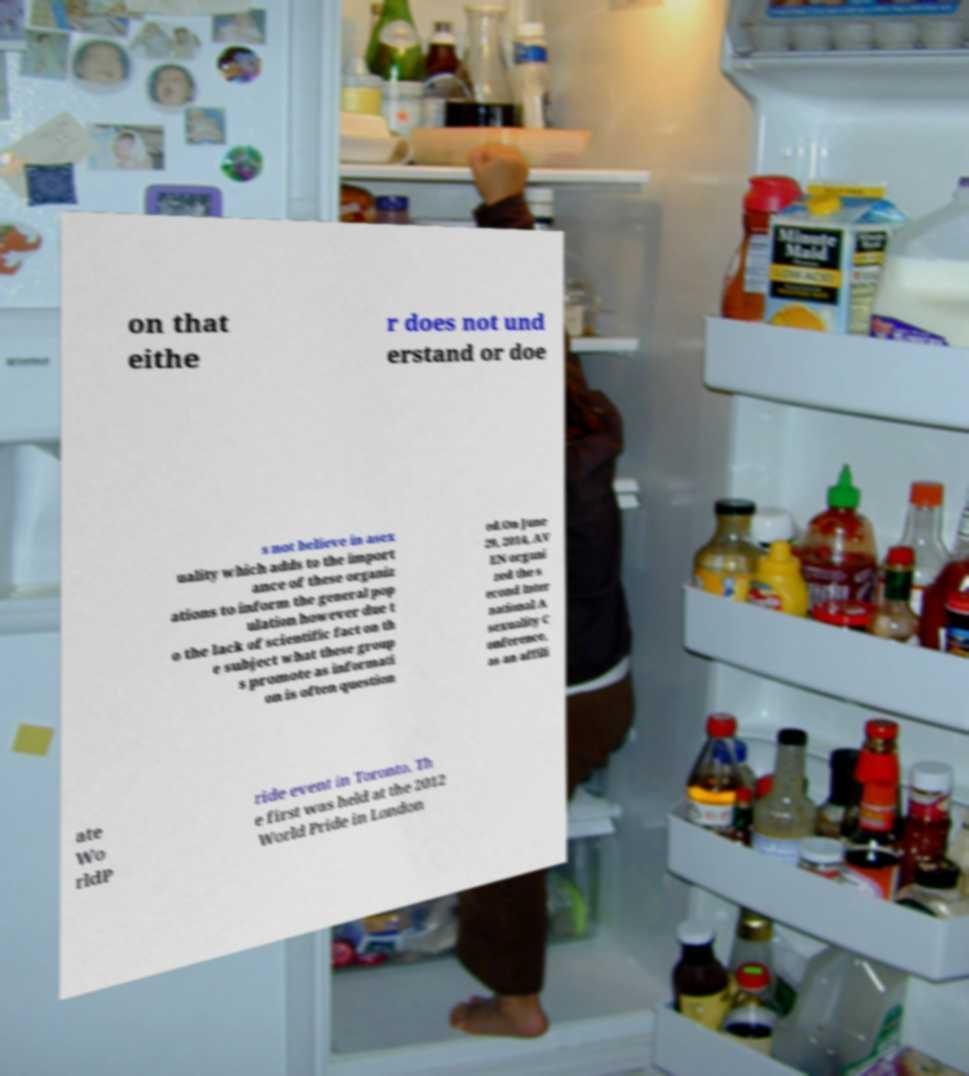Please identify and transcribe the text found in this image. on that eithe r does not und erstand or doe s not believe in asex uality which adds to the import ance of these organiz ations to inform the general pop ulation however due t o the lack of scientific fact on th e subject what these group s promote as informati on is often question ed.On June 29, 2014, AV EN organi zed the s econd Inter national A sexuality C onference, as an affili ate Wo rldP ride event in Toronto. Th e first was held at the 2012 World Pride in London 